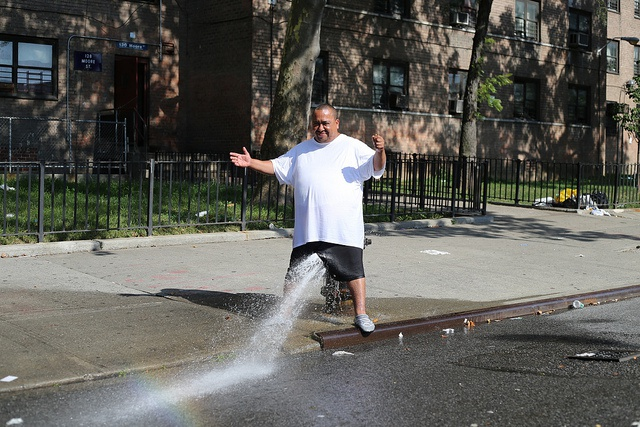Describe the objects in this image and their specific colors. I can see people in black, lavender, and darkgray tones and fire hydrant in black, gray, and maroon tones in this image. 